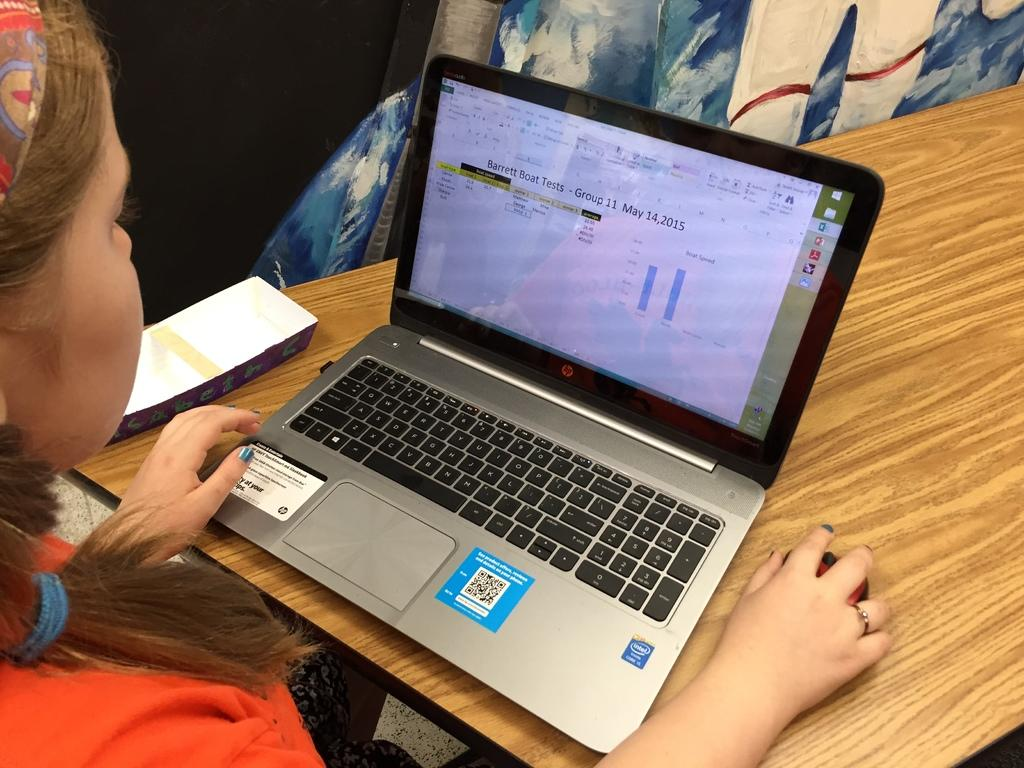Who is the main subject in the image? There is a lady in the image. What is the lady doing in the image? The lady is sitting in front of a table. What can be seen on the table in the image? There is a laptop on the table, and there are other objects on the table as well. What type of seed is being used to power the engine in the image? There is no seed or engine present in the image; it features a lady sitting at a table with a laptop and other objects. 